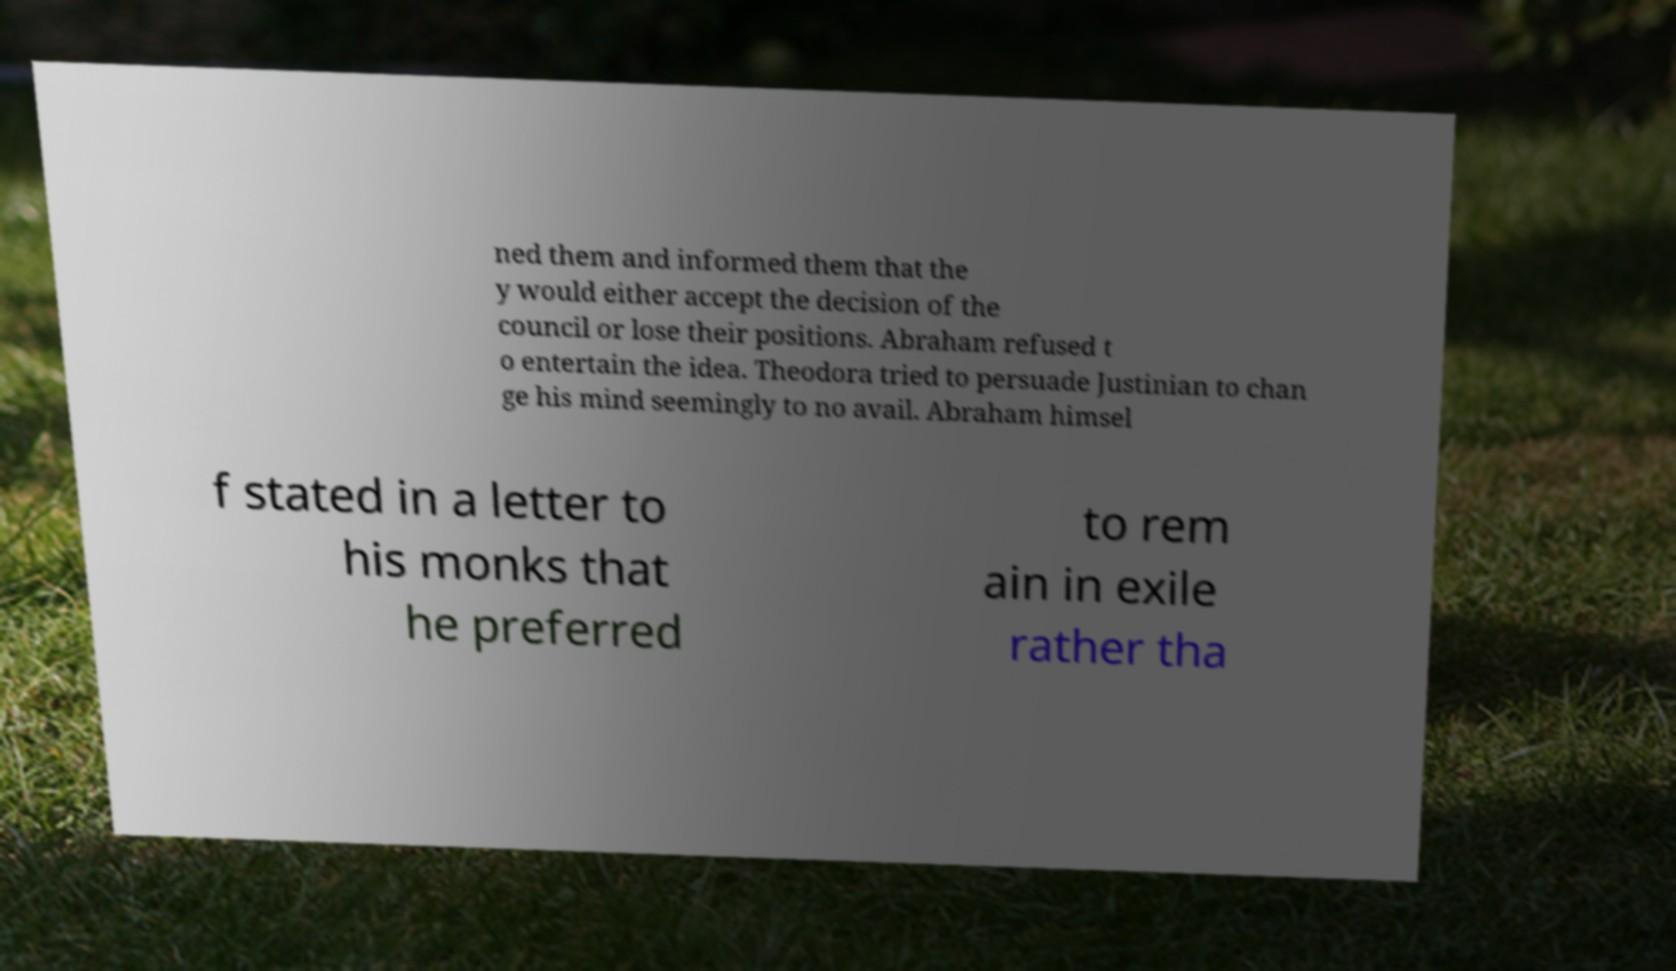For documentation purposes, I need the text within this image transcribed. Could you provide that? ned them and informed them that the y would either accept the decision of the council or lose their positions. Abraham refused t o entertain the idea. Theodora tried to persuade Justinian to chan ge his mind seemingly to no avail. Abraham himsel f stated in a letter to his monks that he preferred to rem ain in exile rather tha 